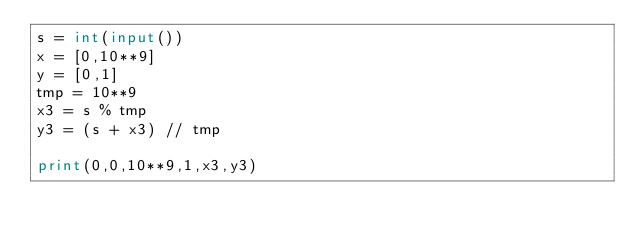Convert code to text. <code><loc_0><loc_0><loc_500><loc_500><_Python_>s = int(input())
x = [0,10**9]
y = [0,1]
tmp = 10**9
x3 = s % tmp
y3 = (s + x3) // tmp

print(0,0,10**9,1,x3,y3)
</code> 